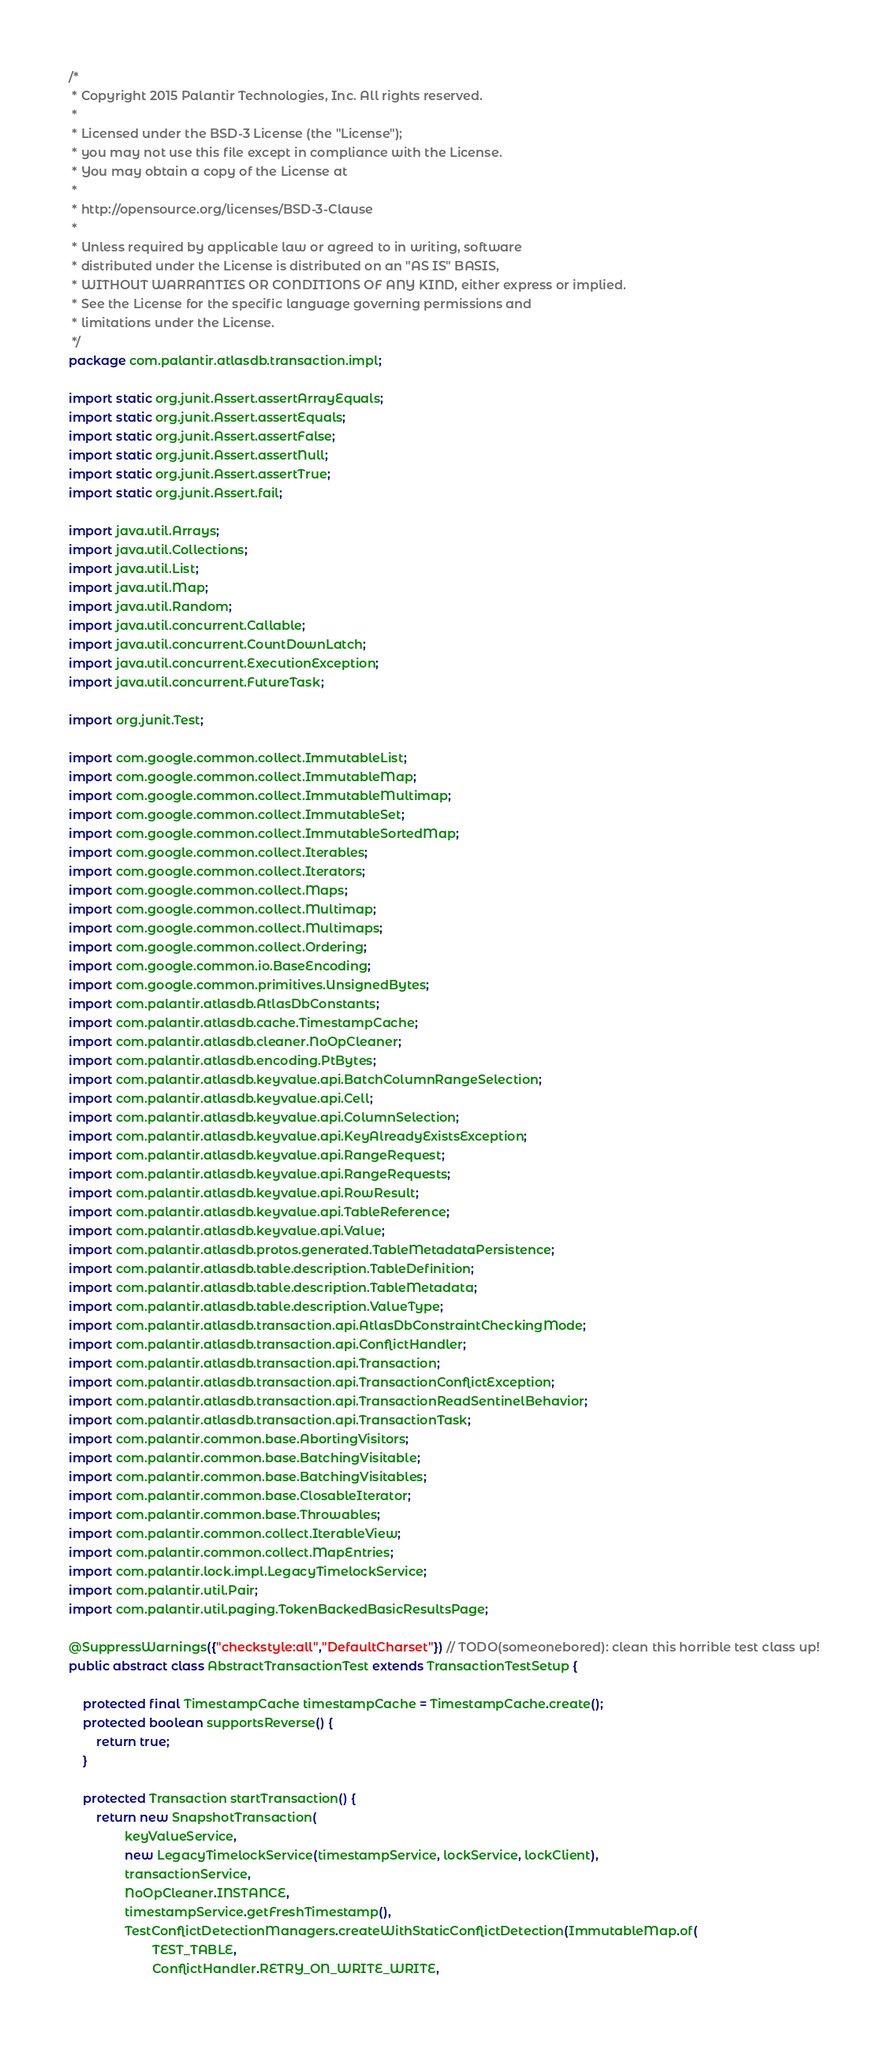<code> <loc_0><loc_0><loc_500><loc_500><_Java_>/*
 * Copyright 2015 Palantir Technologies, Inc. All rights reserved.
 *
 * Licensed under the BSD-3 License (the "License");
 * you may not use this file except in compliance with the License.
 * You may obtain a copy of the License at
 *
 * http://opensource.org/licenses/BSD-3-Clause
 *
 * Unless required by applicable law or agreed to in writing, software
 * distributed under the License is distributed on an "AS IS" BASIS,
 * WITHOUT WARRANTIES OR CONDITIONS OF ANY KIND, either express or implied.
 * See the License for the specific language governing permissions and
 * limitations under the License.
 */
package com.palantir.atlasdb.transaction.impl;

import static org.junit.Assert.assertArrayEquals;
import static org.junit.Assert.assertEquals;
import static org.junit.Assert.assertFalse;
import static org.junit.Assert.assertNull;
import static org.junit.Assert.assertTrue;
import static org.junit.Assert.fail;

import java.util.Arrays;
import java.util.Collections;
import java.util.List;
import java.util.Map;
import java.util.Random;
import java.util.concurrent.Callable;
import java.util.concurrent.CountDownLatch;
import java.util.concurrent.ExecutionException;
import java.util.concurrent.FutureTask;

import org.junit.Test;

import com.google.common.collect.ImmutableList;
import com.google.common.collect.ImmutableMap;
import com.google.common.collect.ImmutableMultimap;
import com.google.common.collect.ImmutableSet;
import com.google.common.collect.ImmutableSortedMap;
import com.google.common.collect.Iterables;
import com.google.common.collect.Iterators;
import com.google.common.collect.Maps;
import com.google.common.collect.Multimap;
import com.google.common.collect.Multimaps;
import com.google.common.collect.Ordering;
import com.google.common.io.BaseEncoding;
import com.google.common.primitives.UnsignedBytes;
import com.palantir.atlasdb.AtlasDbConstants;
import com.palantir.atlasdb.cache.TimestampCache;
import com.palantir.atlasdb.cleaner.NoOpCleaner;
import com.palantir.atlasdb.encoding.PtBytes;
import com.palantir.atlasdb.keyvalue.api.BatchColumnRangeSelection;
import com.palantir.atlasdb.keyvalue.api.Cell;
import com.palantir.atlasdb.keyvalue.api.ColumnSelection;
import com.palantir.atlasdb.keyvalue.api.KeyAlreadyExistsException;
import com.palantir.atlasdb.keyvalue.api.RangeRequest;
import com.palantir.atlasdb.keyvalue.api.RangeRequests;
import com.palantir.atlasdb.keyvalue.api.RowResult;
import com.palantir.atlasdb.keyvalue.api.TableReference;
import com.palantir.atlasdb.keyvalue.api.Value;
import com.palantir.atlasdb.protos.generated.TableMetadataPersistence;
import com.palantir.atlasdb.table.description.TableDefinition;
import com.palantir.atlasdb.table.description.TableMetadata;
import com.palantir.atlasdb.table.description.ValueType;
import com.palantir.atlasdb.transaction.api.AtlasDbConstraintCheckingMode;
import com.palantir.atlasdb.transaction.api.ConflictHandler;
import com.palantir.atlasdb.transaction.api.Transaction;
import com.palantir.atlasdb.transaction.api.TransactionConflictException;
import com.palantir.atlasdb.transaction.api.TransactionReadSentinelBehavior;
import com.palantir.atlasdb.transaction.api.TransactionTask;
import com.palantir.common.base.AbortingVisitors;
import com.palantir.common.base.BatchingVisitable;
import com.palantir.common.base.BatchingVisitables;
import com.palantir.common.base.ClosableIterator;
import com.palantir.common.base.Throwables;
import com.palantir.common.collect.IterableView;
import com.palantir.common.collect.MapEntries;
import com.palantir.lock.impl.LegacyTimelockService;
import com.palantir.util.Pair;
import com.palantir.util.paging.TokenBackedBasicResultsPage;

@SuppressWarnings({"checkstyle:all","DefaultCharset"}) // TODO(someonebored): clean this horrible test class up!
public abstract class AbstractTransactionTest extends TransactionTestSetup {

    protected final TimestampCache timestampCache = TimestampCache.create();
    protected boolean supportsReverse() {
        return true;
    }

    protected Transaction startTransaction() {
        return new SnapshotTransaction(
                keyValueService,
                new LegacyTimelockService(timestampService, lockService, lockClient),
                transactionService,
                NoOpCleaner.INSTANCE,
                timestampService.getFreshTimestamp(),
                TestConflictDetectionManagers.createWithStaticConflictDetection(ImmutableMap.of(
                        TEST_TABLE,
                        ConflictHandler.RETRY_ON_WRITE_WRITE,</code> 